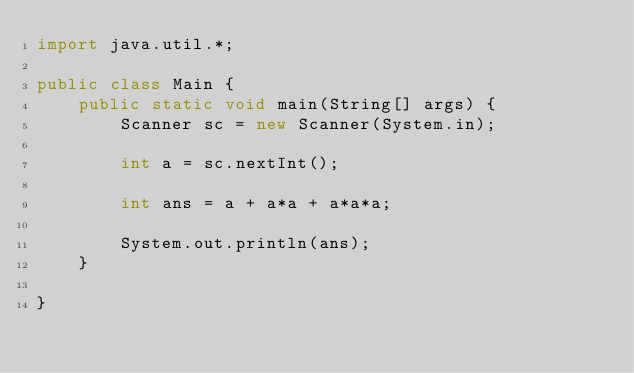<code> <loc_0><loc_0><loc_500><loc_500><_Java_>import java.util.*;

public class Main {
    public static void main(String[] args) {
        Scanner sc = new Scanner(System.in);

        int a = sc.nextInt();
        
        int ans = a + a*a + a*a*a;
        
        System.out.println(ans);
    }

}
</code> 